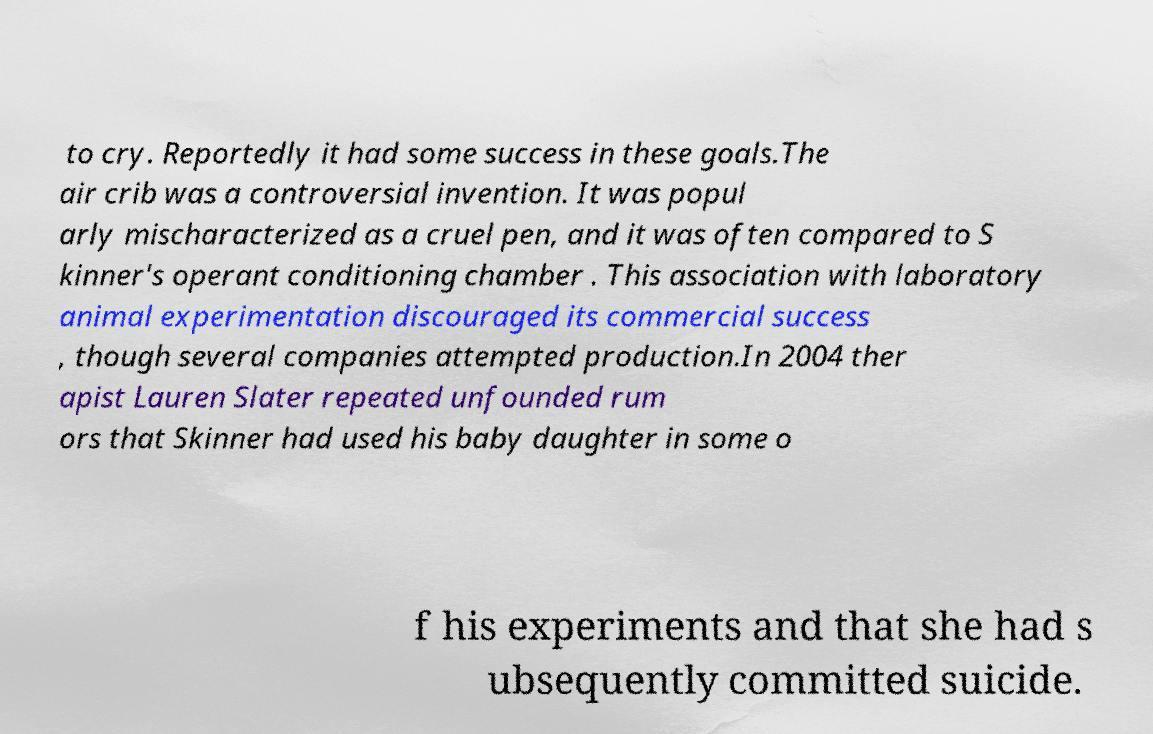For documentation purposes, I need the text within this image transcribed. Could you provide that? to cry. Reportedly it had some success in these goals.The air crib was a controversial invention. It was popul arly mischaracterized as a cruel pen, and it was often compared to S kinner's operant conditioning chamber . This association with laboratory animal experimentation discouraged its commercial success , though several companies attempted production.In 2004 ther apist Lauren Slater repeated unfounded rum ors that Skinner had used his baby daughter in some o f his experiments and that she had s ubsequently committed suicide. 